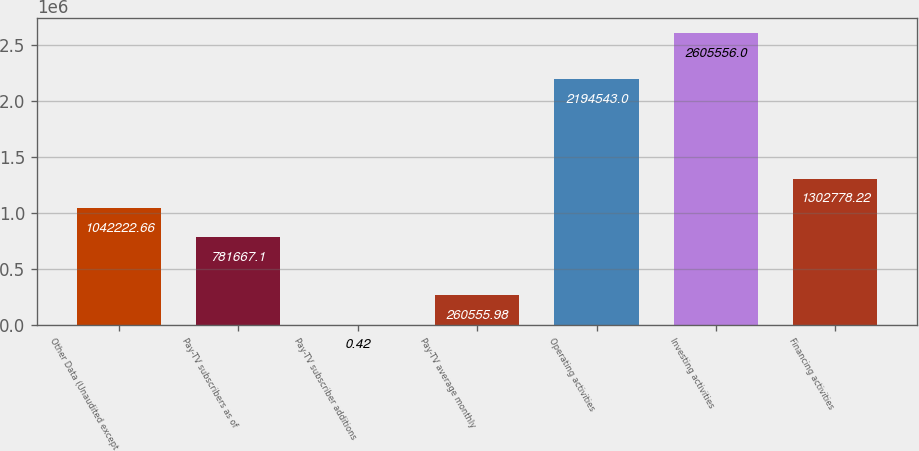Convert chart. <chart><loc_0><loc_0><loc_500><loc_500><bar_chart><fcel>Other Data (Unaudited except<fcel>Pay-TV subscribers as of<fcel>Pay-TV subscriber additions<fcel>Pay-TV average monthly<fcel>Operating activities<fcel>Investing activities<fcel>Financing activities<nl><fcel>1.04222e+06<fcel>781667<fcel>0.42<fcel>260556<fcel>2.19454e+06<fcel>2.60556e+06<fcel>1.30278e+06<nl></chart> 